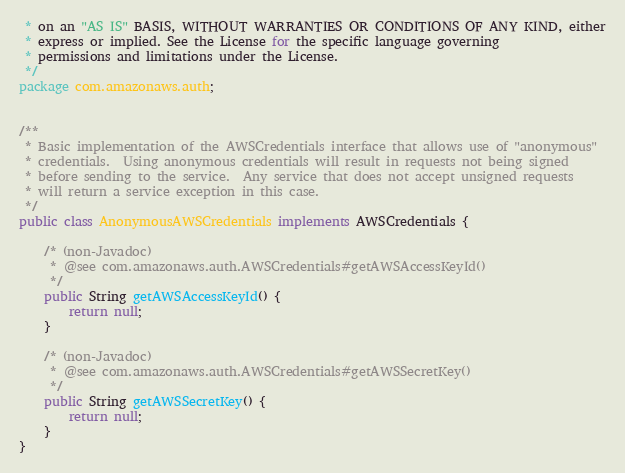Convert code to text. <code><loc_0><loc_0><loc_500><loc_500><_Java_> * on an "AS IS" BASIS, WITHOUT WARRANTIES OR CONDITIONS OF ANY KIND, either
 * express or implied. See the License for the specific language governing
 * permissions and limitations under the License.
 */
package com.amazonaws.auth;


/**
 * Basic implementation of the AWSCredentials interface that allows use of "anonymous"
 * credentials.  Using anonymous credentials will result in requests not being signed
 * before sending to the service.  Any service that does not accept unsigned requests
 * will return a service exception in this case.
 */
public class AnonymousAWSCredentials implements AWSCredentials {

    /* (non-Javadoc)
     * @see com.amazonaws.auth.AWSCredentials#getAWSAccessKeyId()
     */
    public String getAWSAccessKeyId() {
        return null;
    }

    /* (non-Javadoc)
     * @see com.amazonaws.auth.AWSCredentials#getAWSSecretKey()
     */
    public String getAWSSecretKey() {
        return null;
    }
}
</code> 